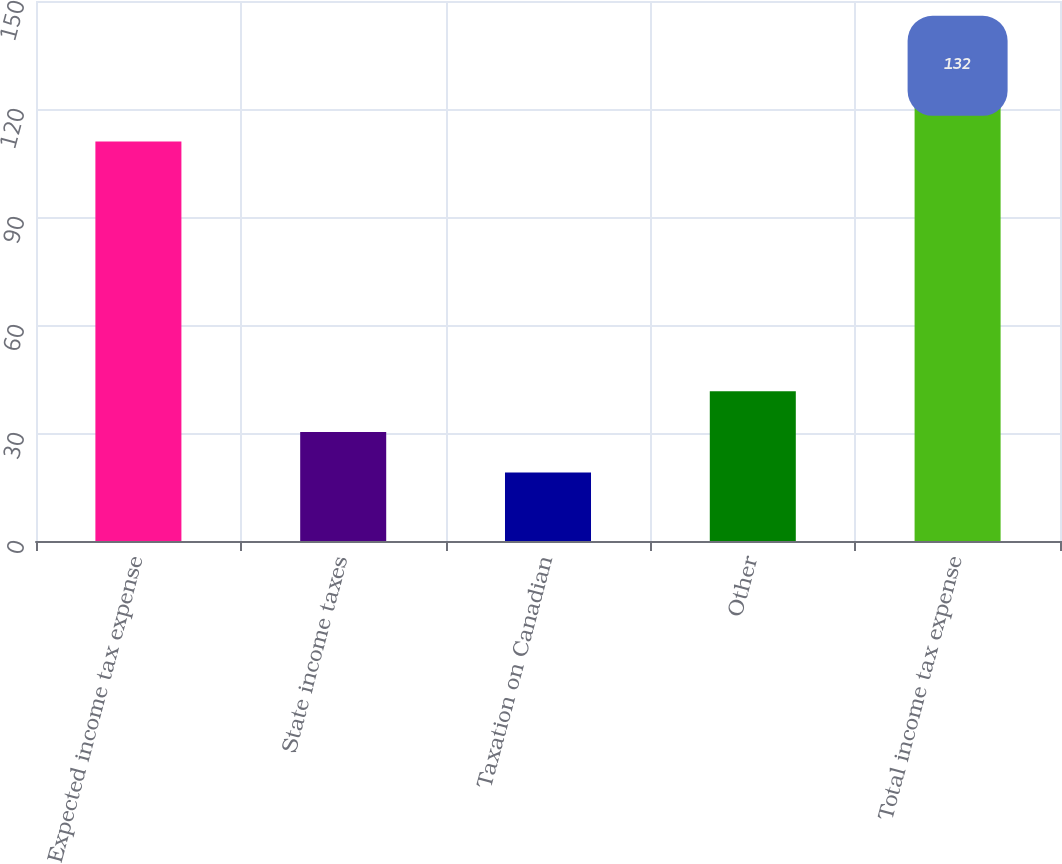<chart> <loc_0><loc_0><loc_500><loc_500><bar_chart><fcel>Expected income tax expense<fcel>State income taxes<fcel>Taxation on Canadian<fcel>Other<fcel>Total income tax expense<nl><fcel>111<fcel>30.3<fcel>19<fcel>41.6<fcel>132<nl></chart> 